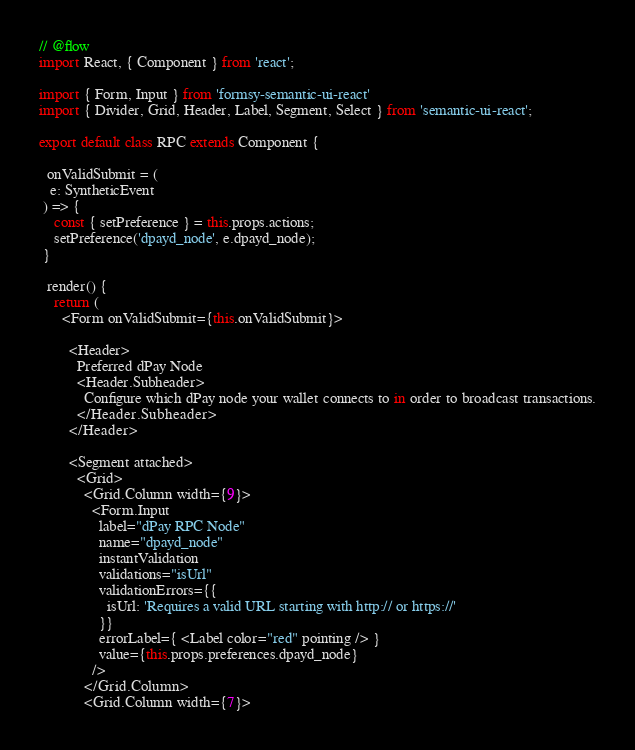Convert code to text. <code><loc_0><loc_0><loc_500><loc_500><_JavaScript_>// @flow
import React, { Component } from 'react';

import { Form, Input } from 'formsy-semantic-ui-react'
import { Divider, Grid, Header, Label, Segment, Select } from 'semantic-ui-react';

export default class RPC extends Component {

  onValidSubmit = (
   e: SyntheticEvent
 ) => {
    const { setPreference } = this.props.actions;
    setPreference('dpayd_node', e.dpayd_node);
 }

  render() {
    return (
      <Form onValidSubmit={this.onValidSubmit}>

        <Header>
          Preferred dPay Node
          <Header.Subheader>
            Configure which dPay node your wallet connects to in order to broadcast transactions.
          </Header.Subheader>
        </Header>

        <Segment attached>
          <Grid>
            <Grid.Column width={9}>
              <Form.Input
                label="dPay RPC Node"
                name="dpayd_node"
                instantValidation
                validations="isUrl"
                validationErrors={{
                  isUrl: 'Requires a valid URL starting with http:// or https://'
                }}
                errorLabel={ <Label color="red" pointing /> }
                value={this.props.preferences.dpayd_node}
              />
            </Grid.Column>
            <Grid.Column width={7}></code> 